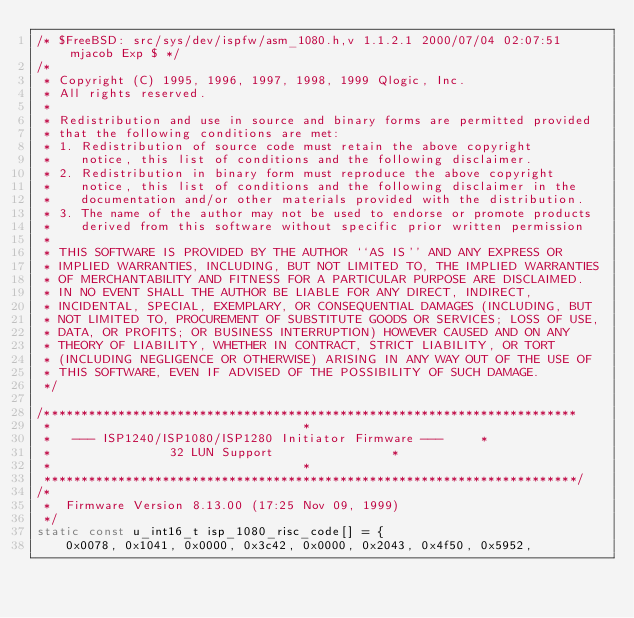Convert code to text. <code><loc_0><loc_0><loc_500><loc_500><_C_>/* $FreeBSD: src/sys/dev/ispfw/asm_1080.h,v 1.1.2.1 2000/07/04 02:07:51 mjacob Exp $ */
/*
 * Copyright (C) 1995, 1996, 1997, 1998, 1999 Qlogic, Inc.
 * All rights reserved.
 *
 * Redistribution and use in source and binary forms are permitted provided
 * that the following conditions are met:
 * 1. Redistribution of source code must retain the above copyright
 *    notice, this list of conditions and the following disclaimer.
 * 2. Redistribution in binary form must reproduce the above copyright
 *    notice, this list of conditions and the following disclaimer in the
 *    documentation and/or other materials provided with the distribution.
 * 3. The name of the author may not be used to endorse or promote products
 *    derived from this software without specific prior written permission
 *
 * THIS SOFTWARE IS PROVIDED BY THE AUTHOR ``AS IS'' AND ANY EXPRESS OR
 * IMPLIED WARRANTIES, INCLUDING, BUT NOT LIMITED TO, THE IMPLIED WARRANTIES
 * OF MERCHANTABILITY AND FITNESS FOR A PARTICULAR PURPOSE ARE DISCLAIMED.
 * IN NO EVENT SHALL THE AUTHOR BE LIABLE FOR ANY DIRECT, INDIRECT,
 * INCIDENTAL, SPECIAL, EXEMPLARY, OR CONSEQUENTIAL DAMAGES (INCLUDING, BUT
 * NOT LIMITED TO, PROCUREMENT OF SUBSTITUTE GOODS OR SERVICES; LOSS OF USE,
 * DATA, OR PROFITS; OR BUSINESS INTERRUPTION) HOWEVER CAUSED AND ON ANY
 * THEORY OF LIABILITY, WHETHER IN CONTRACT, STRICT LIABILITY, OR TORT
 * (INCLUDING NEGLIGENCE OR OTHERWISE) ARISING IN ANY WAY OUT OF THE USE OF
 * THIS SOFTWARE, EVEN IF ADVISED OF THE POSSIBILITY OF SUCH DAMAGE.
 */ 

/************************************************************************
 *									*
 *	 --- ISP1240/ISP1080/ISP1280 Initiator Firmware ---		*
 *			      32 LUN Support				*
 *									*
 ************************************************************************/
/*
 *	Firmware Version 8.13.00 (17:25 Nov 09, 1999)
 */
static const u_int16_t isp_1080_risc_code[] = {
	0x0078, 0x1041, 0x0000, 0x3c42, 0x0000, 0x2043, 0x4f50, 0x5952,</code> 